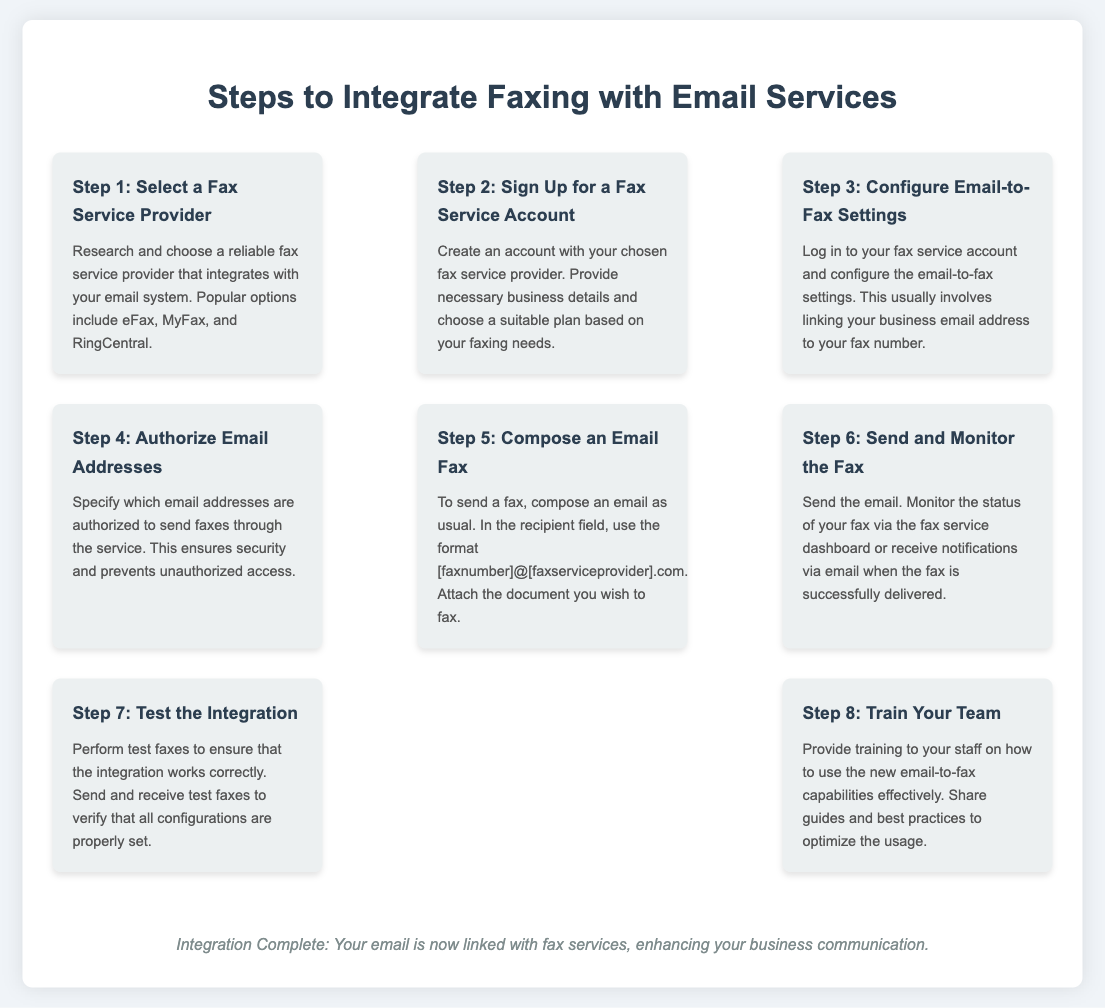what is the first step in the integration process? The first step is to select a fax service provider.
Answer: Select a Fax Service Provider how many steps are there to integrate faxing with email services? The document lists a total of eight steps in the integration process.
Answer: Eight which step involves composing an email fax? The step that involves composing an email fax is Step 5.
Answer: Step 5 what should you do after sending the email fax? After sending the email fax, you should monitor the status of your fax.
Answer: Monitor the status of your fax which icon represents the step to authorize email addresses? The icon representing the step to authorize email addresses is a shield icon.
Answer: Shield icon what is the last step in the integration process? The last step in the integration process is to train your team.
Answer: Train Your Team which fax service providers are mentioned as options? The options mentioned are eFax, MyFax, and RingCentral.
Answer: eFax, MyFax, RingCentral what do you need to attach when composing an email fax? You need to attach the document you wish to fax.
Answer: The document you wish to fax what is the main benefit of integrating fax services with email? The main benefit is enhancing business communication.
Answer: Enhancing business communication 